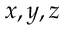<formula> <loc_0><loc_0><loc_500><loc_500>x , y , z</formula> 